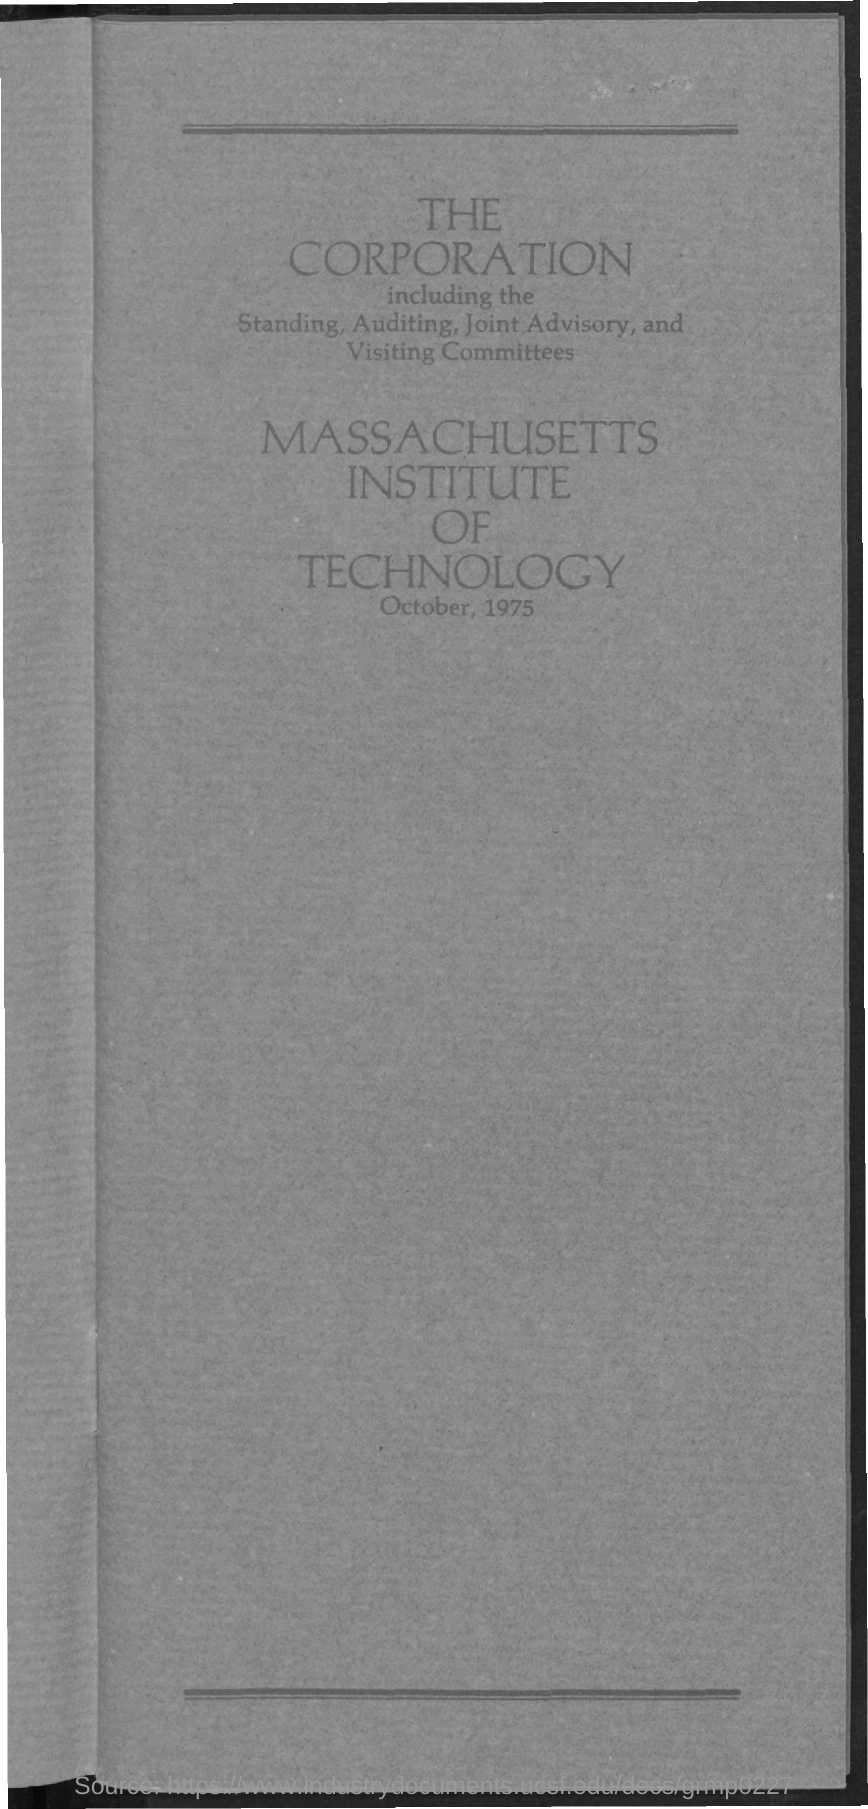Which institution is mentioned?
Provide a succinct answer. Massachusetts Institute of Technology. What is the date given?
Give a very brief answer. October, 1975. 